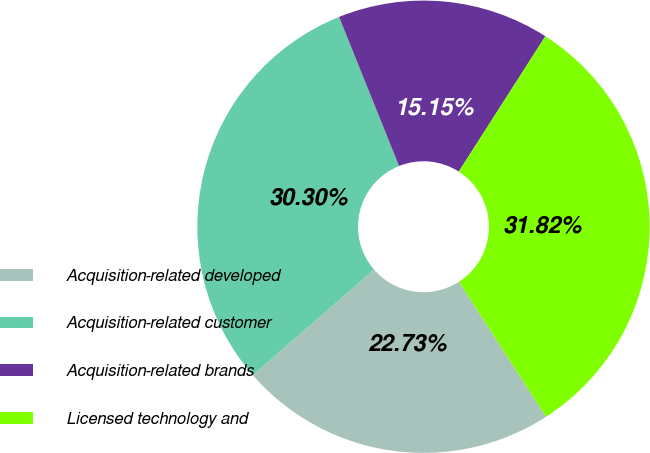Convert chart to OTSL. <chart><loc_0><loc_0><loc_500><loc_500><pie_chart><fcel>Acquisition-related developed<fcel>Acquisition-related customer<fcel>Acquisition-related brands<fcel>Licensed technology and<nl><fcel>22.73%<fcel>30.3%<fcel>15.15%<fcel>31.82%<nl></chart> 